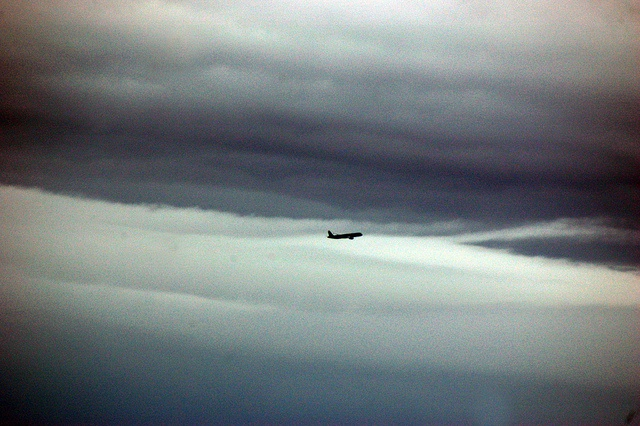Describe the objects in this image and their specific colors. I can see a airplane in gray, black, and purple tones in this image. 